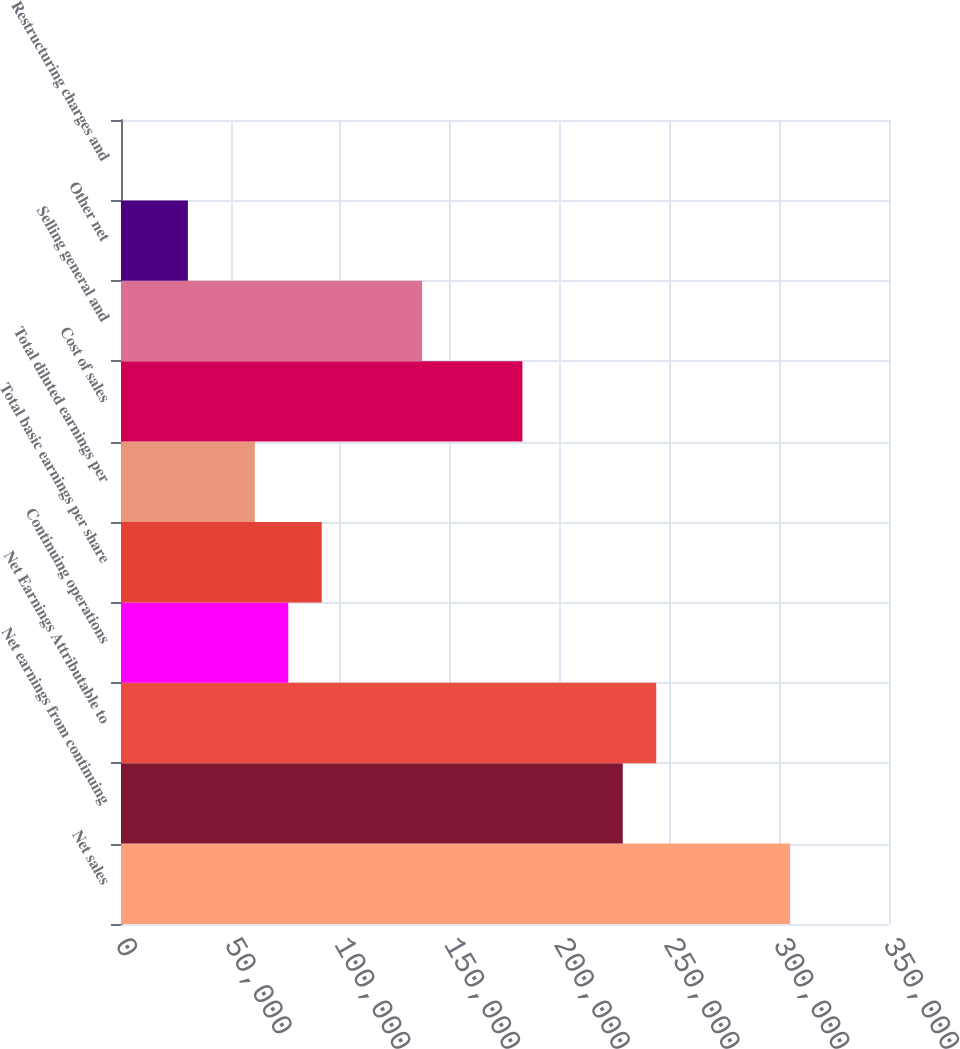<chart> <loc_0><loc_0><loc_500><loc_500><bar_chart><fcel>Net sales<fcel>Net earnings from continuing<fcel>Net Earnings Attributable to<fcel>Continuing operations<fcel>Total basic earnings per share<fcel>Total diluted earnings per<fcel>Cost of sales<fcel>Selling general and<fcel>Other net<fcel>Restructuring charges and<nl><fcel>304898<fcel>228673<fcel>243918<fcel>76224.7<fcel>91469.6<fcel>60979.8<fcel>182939<fcel>137204<fcel>30490.1<fcel>0.4<nl></chart> 